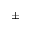<formula> <loc_0><loc_0><loc_500><loc_500>\pm</formula> 